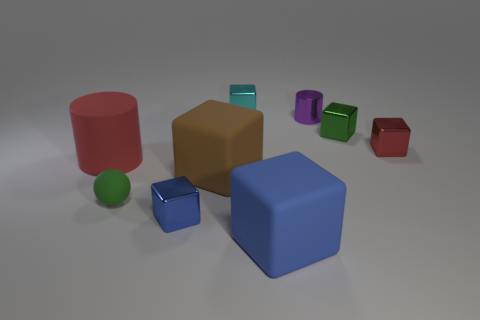There is a metal object behind the small purple object; does it have the same shape as the tiny green rubber thing?
Offer a very short reply. No. Is there anything else that has the same shape as the cyan thing?
Offer a terse response. Yes. How many cylinders are small cyan rubber objects or small purple shiny things?
Provide a succinct answer. 1. What number of green shiny balls are there?
Offer a very short reply. 0. How big is the cylinder to the left of the big thing that is right of the brown thing?
Your answer should be very brief. Large. What number of other objects are the same size as the green metallic object?
Your response must be concise. 5. There is a large brown matte cube; what number of green matte balls are behind it?
Ensure brevity in your answer.  0. What is the size of the cyan metallic cube?
Your answer should be compact. Small. Are the cylinder to the right of the matte cylinder and the tiny green object that is in front of the red rubber cylinder made of the same material?
Your response must be concise. No. Is there a small shiny cylinder of the same color as the tiny rubber object?
Your answer should be very brief. No. 